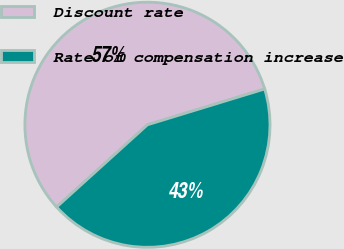Convert chart to OTSL. <chart><loc_0><loc_0><loc_500><loc_500><pie_chart><fcel>Discount rate<fcel>Rate of compensation increase<nl><fcel>56.99%<fcel>43.01%<nl></chart> 